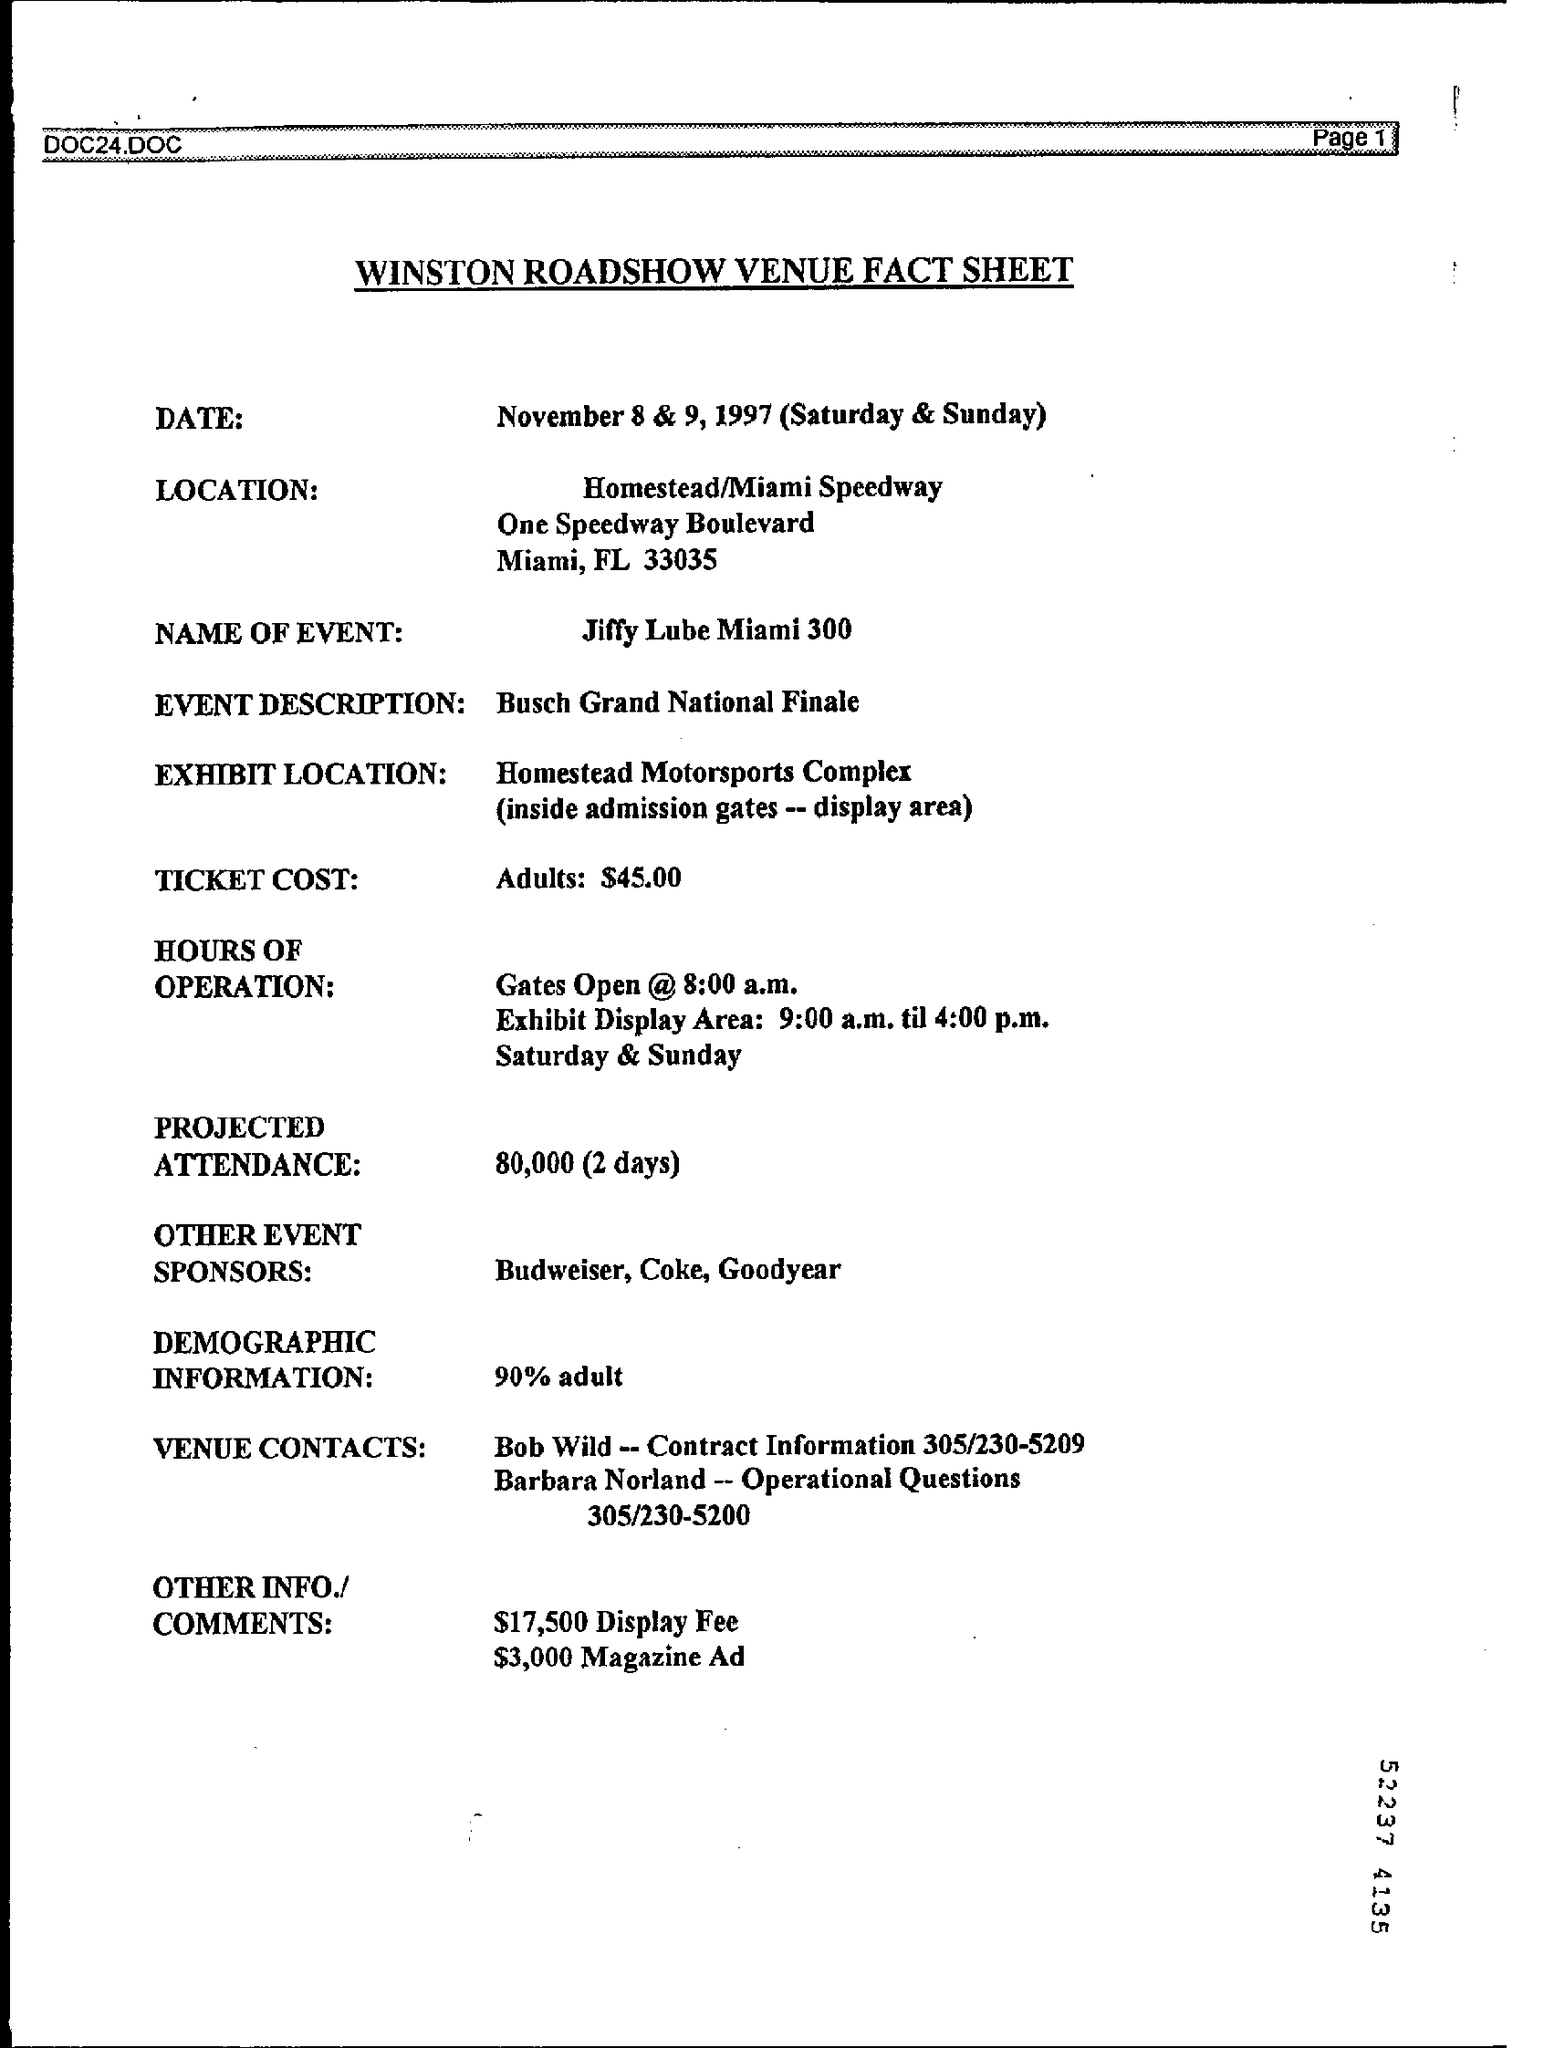List a handful of essential elements in this visual. This sheet is the heading of the WINSTON ROADSHOW VENUE FACT SHEET. The ticket cost for the event is $45.00 for adults. The name of the event listed in the sheet is Jiffy LUBE Miami 300. 